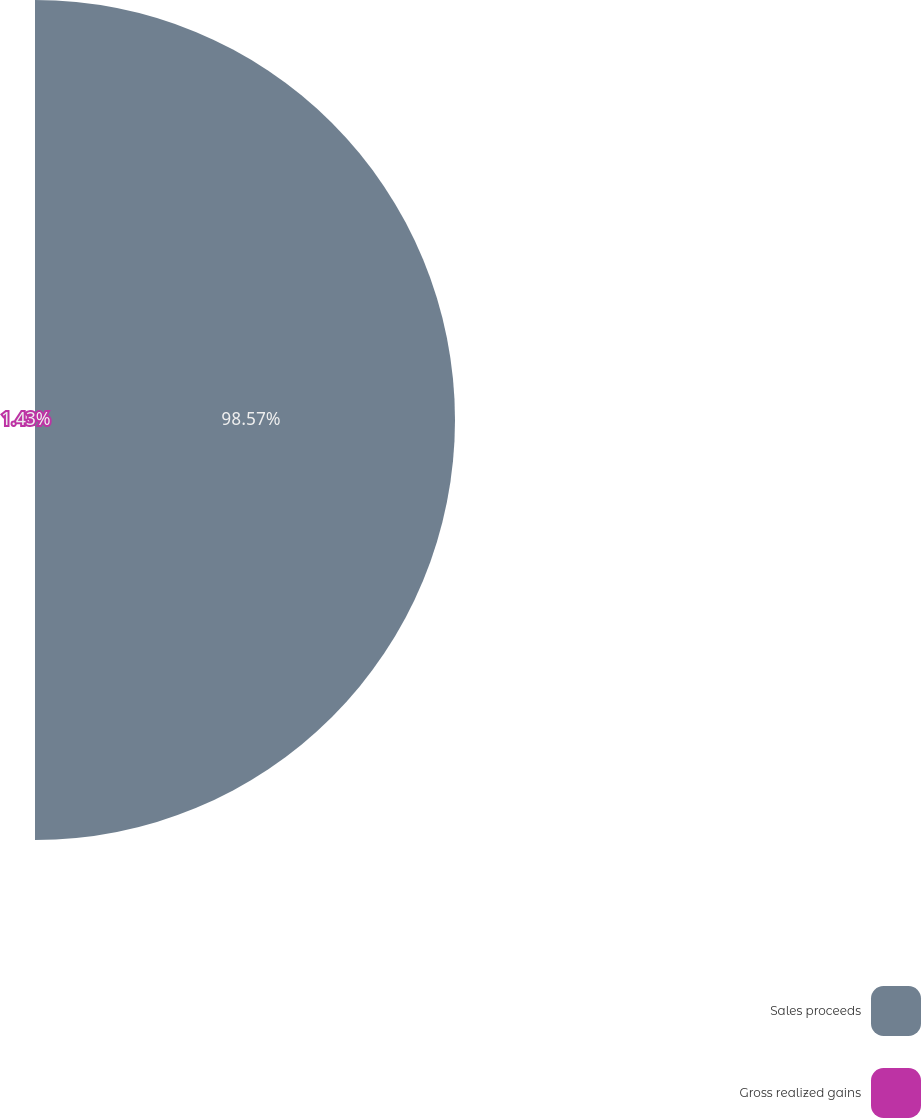<chart> <loc_0><loc_0><loc_500><loc_500><pie_chart><fcel>Sales proceeds<fcel>Gross realized gains<nl><fcel>98.57%<fcel>1.43%<nl></chart> 